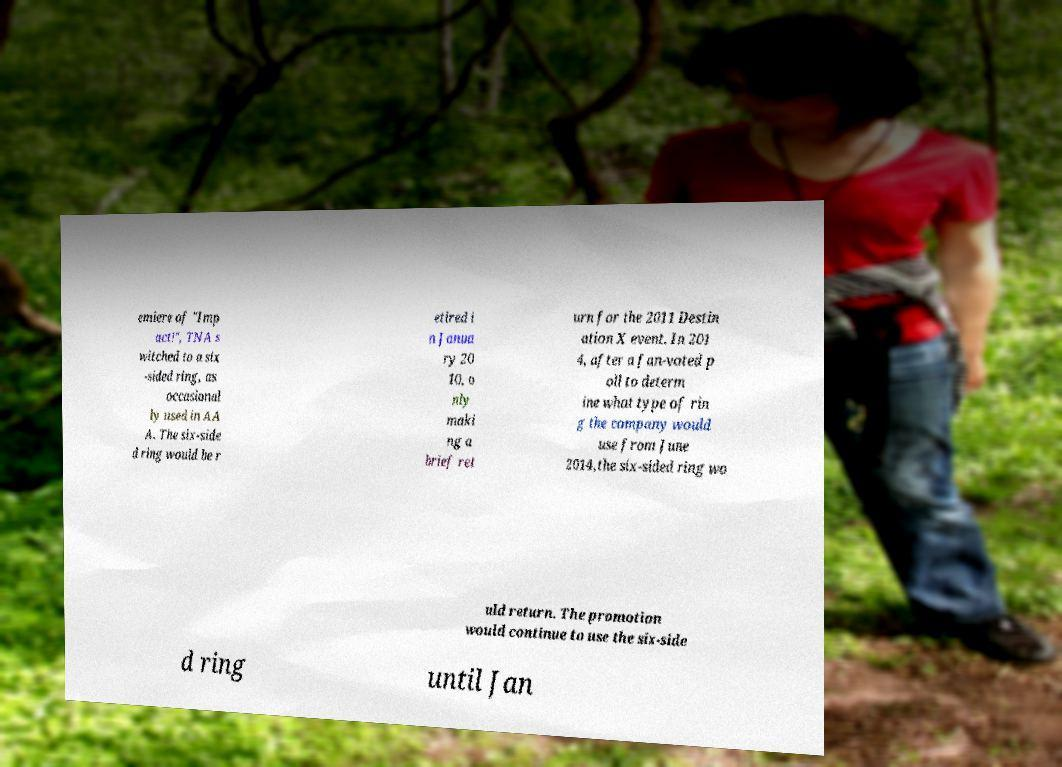Can you read and provide the text displayed in the image?This photo seems to have some interesting text. Can you extract and type it out for me? emiere of "Imp act!", TNA s witched to a six -sided ring, as occasional ly used in AA A. The six-side d ring would be r etired i n Janua ry 20 10, o nly maki ng a brief ret urn for the 2011 Destin ation X event. In 201 4, after a fan-voted p oll to determ ine what type of rin g the company would use from June 2014,the six-sided ring wo uld return. The promotion would continue to use the six-side d ring until Jan 